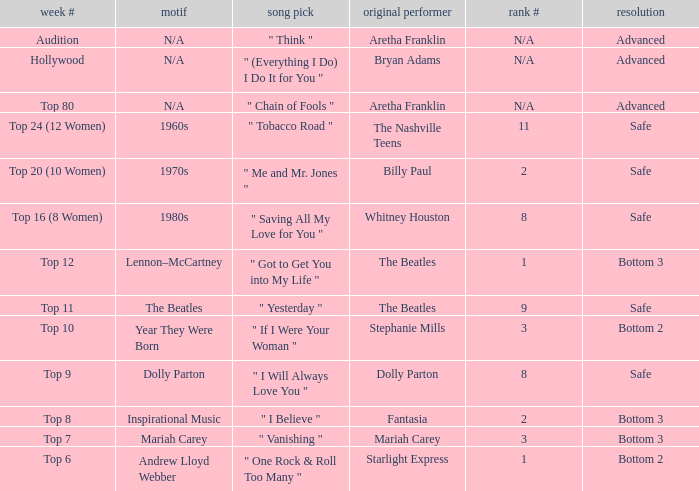Name the order number for the beatles and result is safe 9.0. 